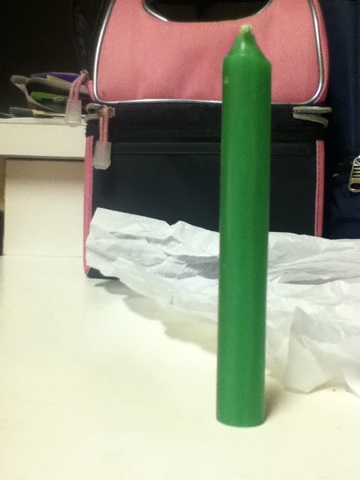What color is this candle? The candle showcased in the image is a vivid shade of green. This color could bring a sense of calm and harmony to any setting where it's used. 